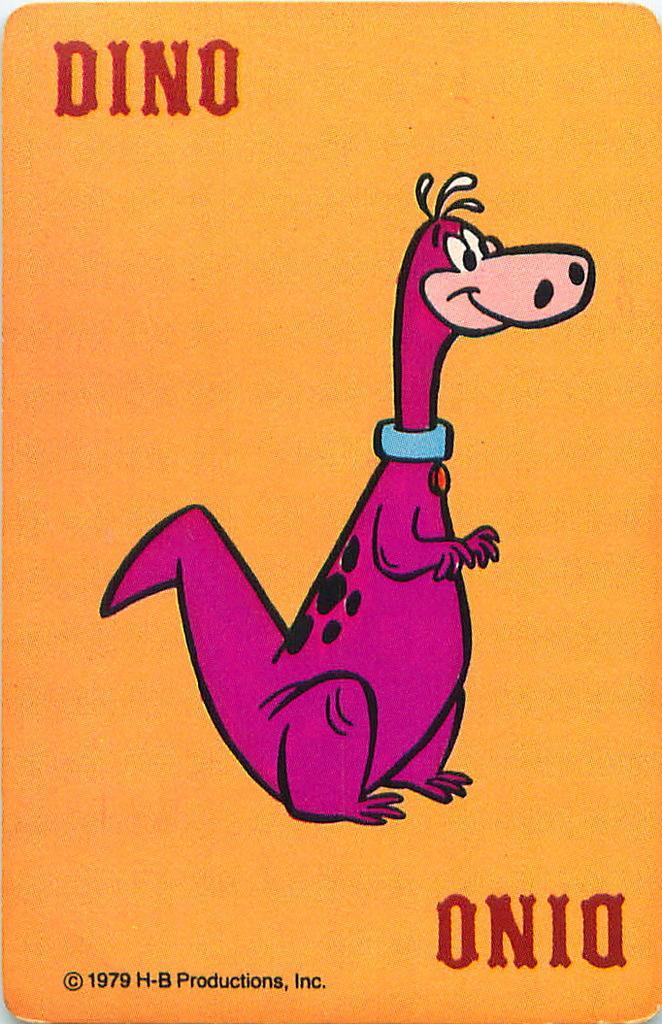Please provide a concise description of this image. This is a poster, on this poster we can see an animal and some text on it. 